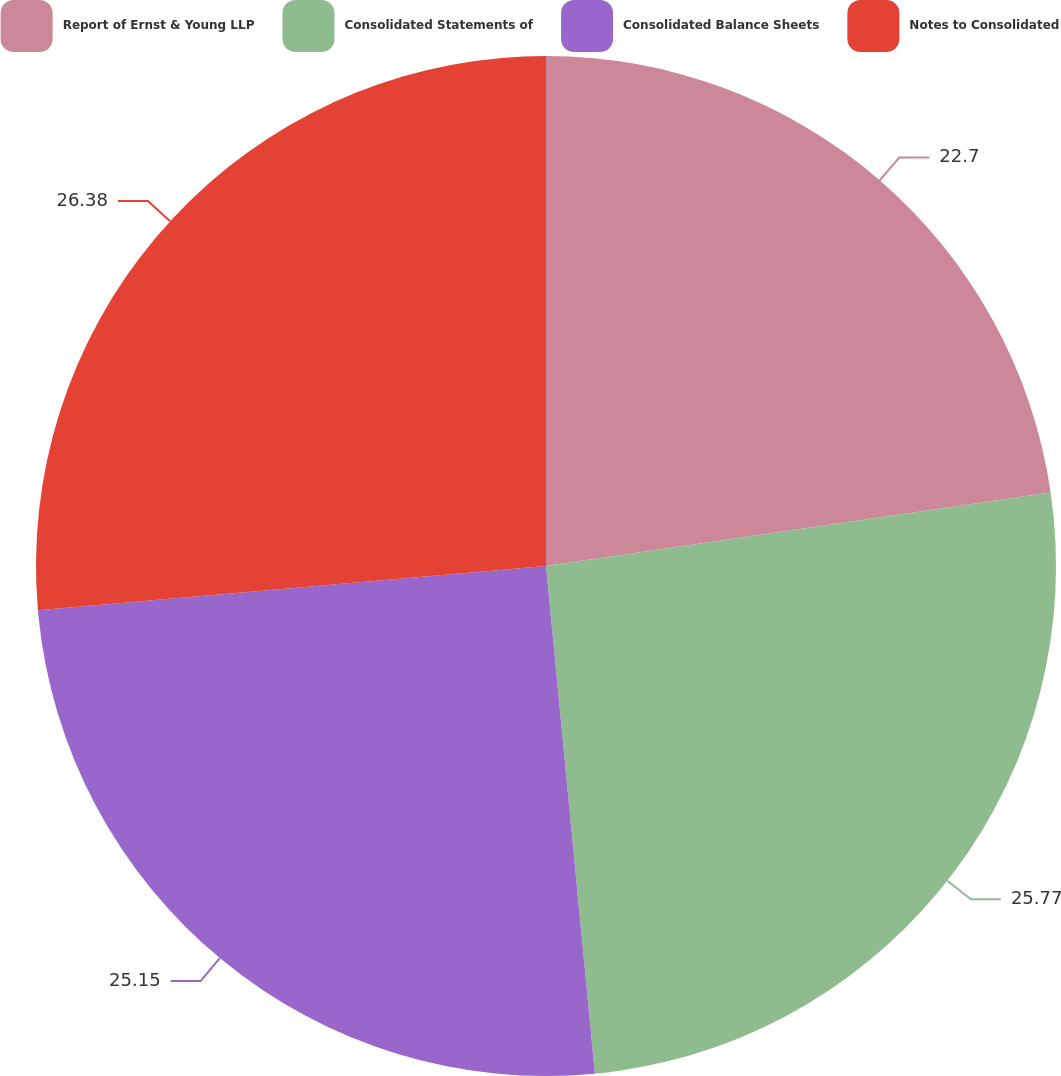Convert chart. <chart><loc_0><loc_0><loc_500><loc_500><pie_chart><fcel>Report of Ernst & Young LLP<fcel>Consolidated Statements of<fcel>Consolidated Balance Sheets<fcel>Notes to Consolidated<nl><fcel>22.7%<fcel>25.77%<fcel>25.15%<fcel>26.38%<nl></chart> 